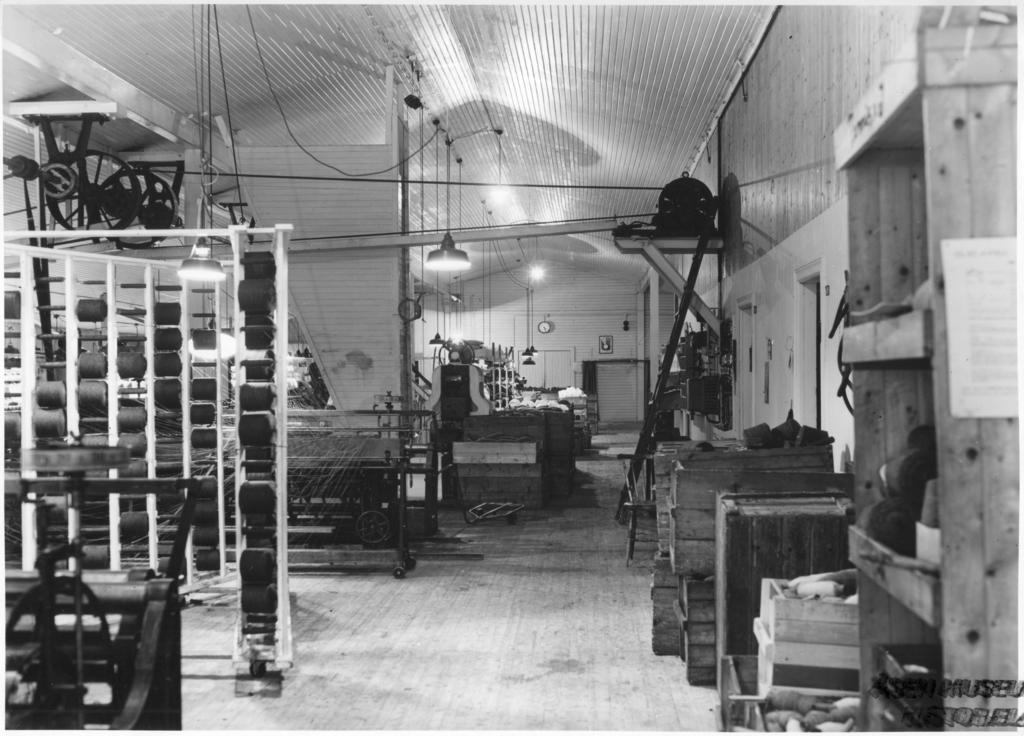Describe this image in one or two sentences. In this image we can see inside view of a room, there are boxes and a shelf with few objects, there is a stand and there are lights hanged and wheels to the ceiling and there are few objects in the room. 